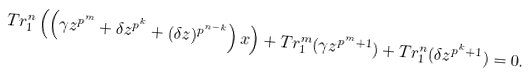<formula> <loc_0><loc_0><loc_500><loc_500>T r _ { 1 } ^ { n } \left ( \left ( \gamma z ^ { p ^ { m } } + \delta z ^ { p ^ { k } } + ( \delta z ) ^ { p ^ { n - k } } \right ) x \right ) + T r _ { 1 } ^ { m } ( \gamma z ^ { p ^ { m } + 1 } ) + T r _ { 1 } ^ { n } ( \delta z ^ { p ^ { k } + 1 } ) = 0 .</formula> 